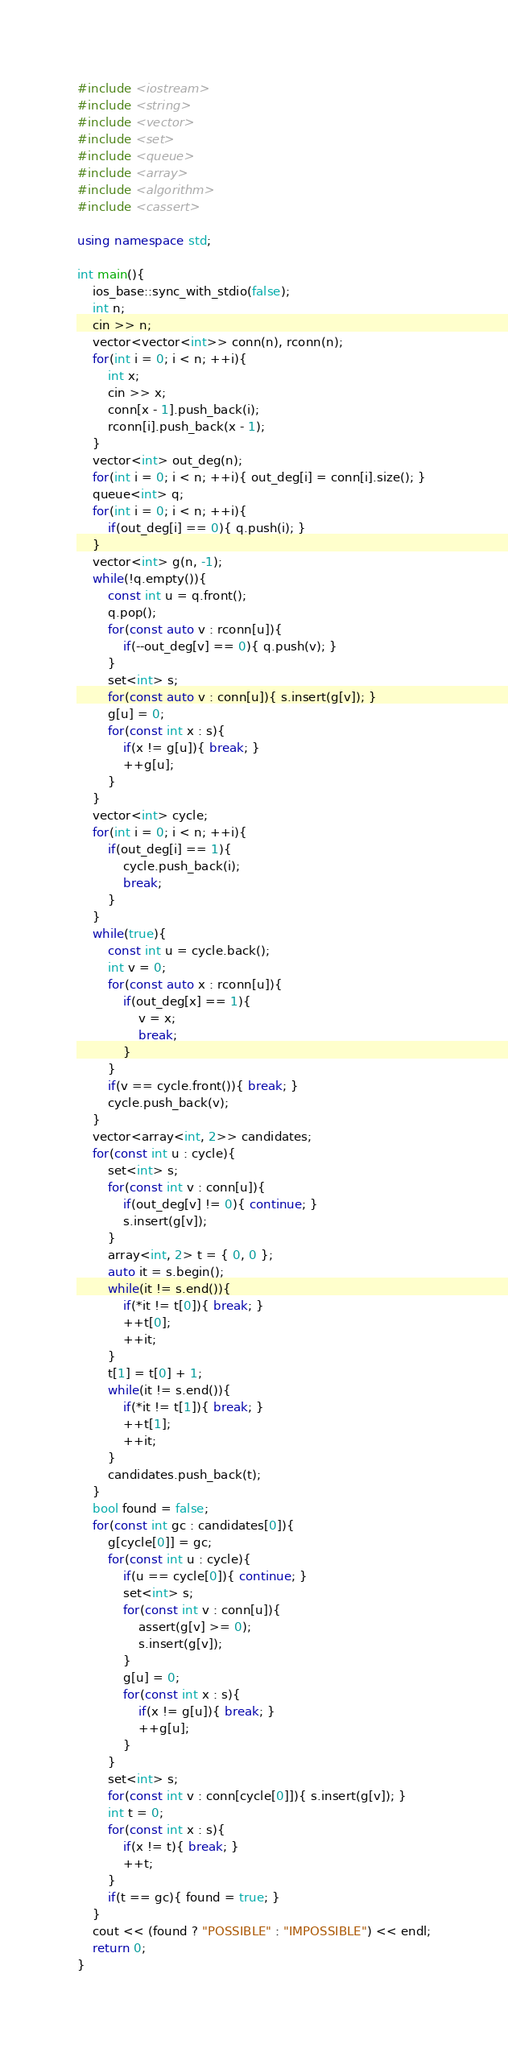Convert code to text. <code><loc_0><loc_0><loc_500><loc_500><_C++_>#include <iostream>
#include <string>
#include <vector>
#include <set>
#include <queue>
#include <array>
#include <algorithm>
#include <cassert>

using namespace std;

int main(){
	ios_base::sync_with_stdio(false);
	int n;
	cin >> n;
	vector<vector<int>> conn(n), rconn(n);
	for(int i = 0; i < n; ++i){
		int x;
		cin >> x;
		conn[x - 1].push_back(i);
		rconn[i].push_back(x - 1);
	}
	vector<int> out_deg(n);
	for(int i = 0; i < n; ++i){ out_deg[i] = conn[i].size(); }
	queue<int> q;
	for(int i = 0; i < n; ++i){
		if(out_deg[i] == 0){ q.push(i); }
	}
	vector<int> g(n, -1);
	while(!q.empty()){
		const int u = q.front();
		q.pop();
		for(const auto v : rconn[u]){
			if(--out_deg[v] == 0){ q.push(v); }
		}
		set<int> s;
		for(const auto v : conn[u]){ s.insert(g[v]); }
		g[u] = 0;
		for(const int x : s){
			if(x != g[u]){ break; }
			++g[u];
		}
	}
	vector<int> cycle;
	for(int i = 0; i < n; ++i){
		if(out_deg[i] == 1){
			cycle.push_back(i);
			break;
		}
	}
	while(true){
		const int u = cycle.back();
		int v = 0;
		for(const auto x : rconn[u]){
			if(out_deg[x] == 1){
				v = x;
				break;
			}
		}
		if(v == cycle.front()){ break; }
		cycle.push_back(v);
	}
	vector<array<int, 2>> candidates;
	for(const int u : cycle){
		set<int> s;
		for(const int v : conn[u]){
			if(out_deg[v] != 0){ continue; }
			s.insert(g[v]);
		}
		array<int, 2> t = { 0, 0 };
		auto it = s.begin();
		while(it != s.end()){
			if(*it != t[0]){ break; }
			++t[0];
			++it;
		}
		t[1] = t[0] + 1;
		while(it != s.end()){
			if(*it != t[1]){ break; }
			++t[1];
			++it;
		}
		candidates.push_back(t);
	}
	bool found = false;
	for(const int gc : candidates[0]){
		g[cycle[0]] = gc;
		for(const int u : cycle){
			if(u == cycle[0]){ continue; }
			set<int> s;
			for(const int v : conn[u]){
				assert(g[v] >= 0);
				s.insert(g[v]);
			}
			g[u] = 0;
			for(const int x : s){
				if(x != g[u]){ break; }
				++g[u];
			}
		}
		set<int> s;
		for(const int v : conn[cycle[0]]){ s.insert(g[v]); }
		int t = 0;
		for(const int x : s){
			if(x != t){ break; }
			++t;
		}
		if(t == gc){ found = true; }
	}
	cout << (found ? "POSSIBLE" : "IMPOSSIBLE") << endl;
	return 0;
}

</code> 